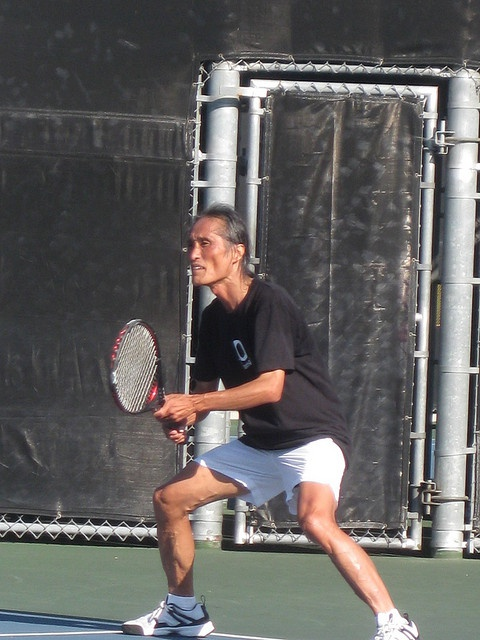Describe the objects in this image and their specific colors. I can see people in black, gray, tan, and white tones and tennis racket in black, darkgray, gray, lightgray, and maroon tones in this image. 